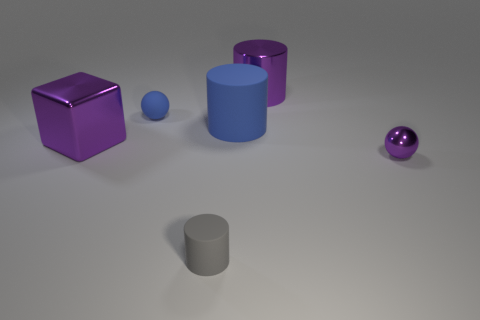Subtract all gray balls. Subtract all red cubes. How many balls are left? 2 Add 2 small blue things. How many objects exist? 8 Subtract all balls. How many objects are left? 4 Add 5 metal spheres. How many metal spheres exist? 6 Subtract 0 brown balls. How many objects are left? 6 Subtract all green objects. Subtract all small blue matte balls. How many objects are left? 5 Add 2 rubber cylinders. How many rubber cylinders are left? 4 